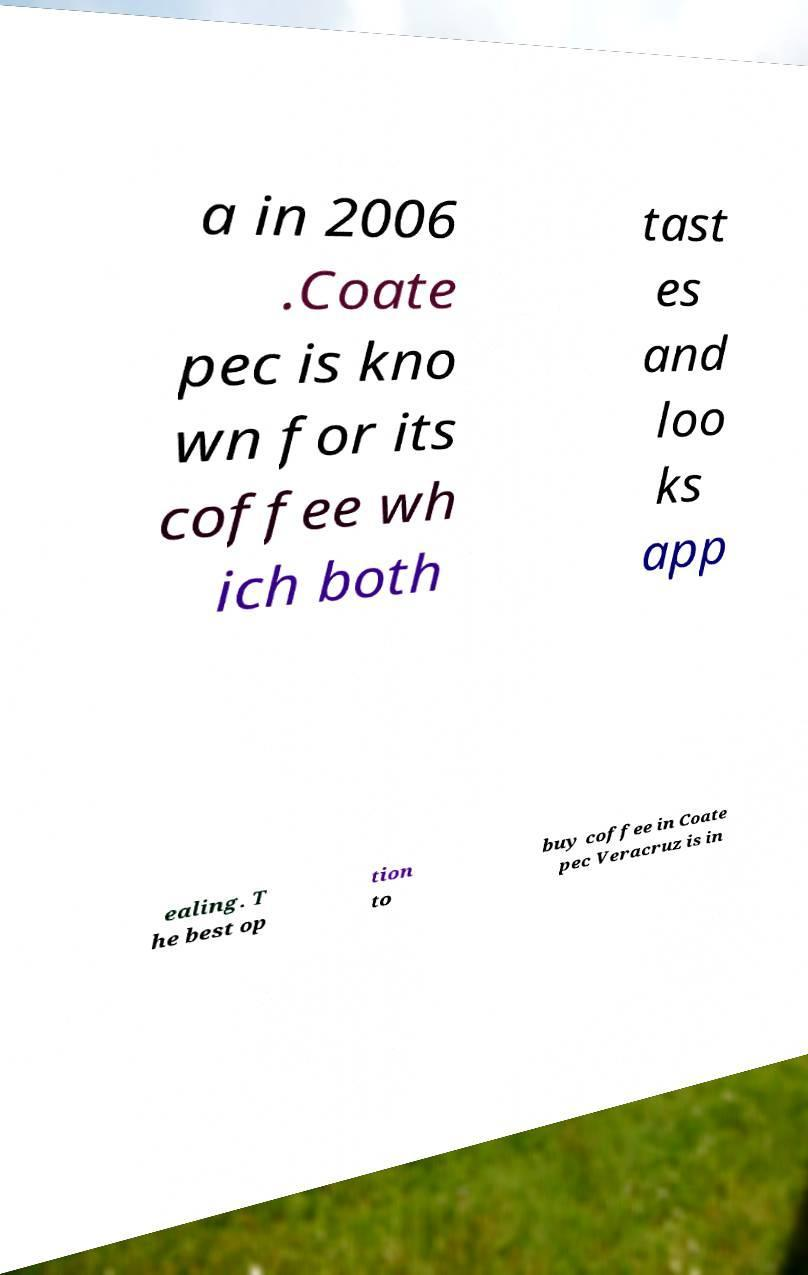Please read and relay the text visible in this image. What does it say? a in 2006 .Coate pec is kno wn for its coffee wh ich both tast es and loo ks app ealing. T he best op tion to buy coffee in Coate pec Veracruz is in 